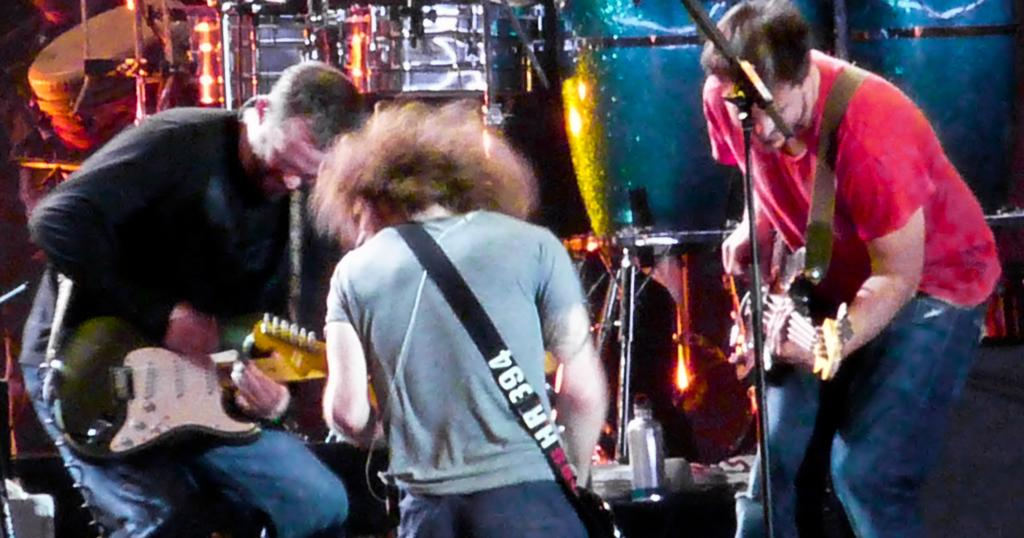How many people are in the image? There are three people in the image. What are the people doing in the image? The three people are playing guitar. Can you describe any other objects or elements in the image? There are musical instruments in the background of the image. What type of brick is being used to make lunch in the image? There is no brick or lunch being prepared in the image; it features three people playing guitar. 